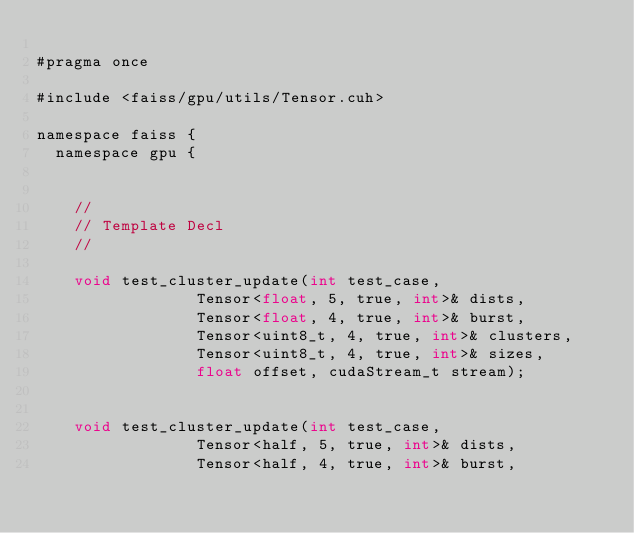Convert code to text. <code><loc_0><loc_0><loc_500><loc_500><_Cuda_>
#pragma once

#include <faiss/gpu/utils/Tensor.cuh>

namespace faiss {
  namespace gpu {


    //
    // Template Decl
    //
    
    void test_cluster_update(int test_case,
			     Tensor<float, 5, true, int>& dists,
			     Tensor<float, 4, true, int>& burst,
			     Tensor<uint8_t, 4, true, int>& clusters,
			     Tensor<uint8_t, 4, true, int>& sizes,
			     float offset, cudaStream_t stream);


    void test_cluster_update(int test_case,
			     Tensor<half, 5, true, int>& dists,
			     Tensor<half, 4, true, int>& burst,</code> 